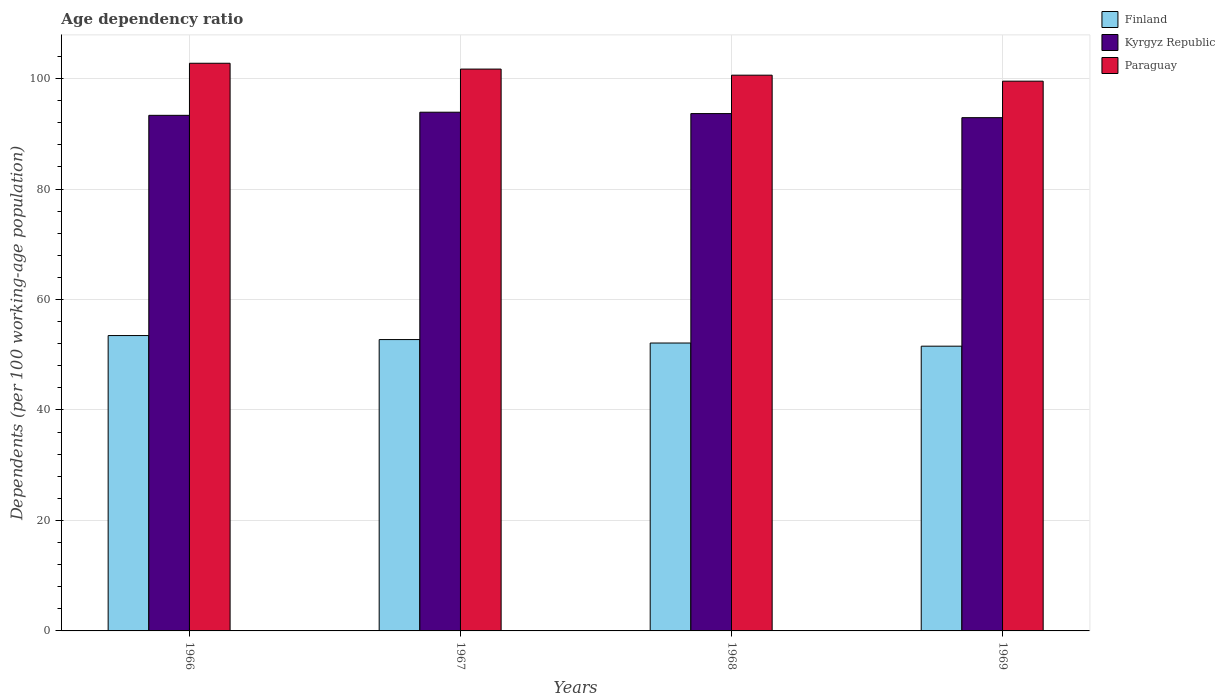How many groups of bars are there?
Provide a succinct answer. 4. How many bars are there on the 2nd tick from the right?
Provide a succinct answer. 3. What is the label of the 1st group of bars from the left?
Provide a short and direct response. 1966. What is the age dependency ratio in in Paraguay in 1969?
Provide a short and direct response. 99.53. Across all years, what is the maximum age dependency ratio in in Finland?
Your response must be concise. 53.48. Across all years, what is the minimum age dependency ratio in in Finland?
Your response must be concise. 51.55. In which year was the age dependency ratio in in Paraguay maximum?
Offer a terse response. 1966. In which year was the age dependency ratio in in Paraguay minimum?
Give a very brief answer. 1969. What is the total age dependency ratio in in Kyrgyz Republic in the graph?
Offer a very short reply. 373.85. What is the difference between the age dependency ratio in in Finland in 1966 and that in 1967?
Give a very brief answer. 0.73. What is the difference between the age dependency ratio in in Finland in 1968 and the age dependency ratio in in Paraguay in 1966?
Your answer should be compact. -50.65. What is the average age dependency ratio in in Paraguay per year?
Offer a very short reply. 101.16. In the year 1966, what is the difference between the age dependency ratio in in Finland and age dependency ratio in in Paraguay?
Provide a succinct answer. -49.3. In how many years, is the age dependency ratio in in Kyrgyz Republic greater than 100 %?
Provide a short and direct response. 0. What is the ratio of the age dependency ratio in in Kyrgyz Republic in 1966 to that in 1968?
Keep it short and to the point. 1. What is the difference between the highest and the second highest age dependency ratio in in Paraguay?
Ensure brevity in your answer.  1.06. What is the difference between the highest and the lowest age dependency ratio in in Kyrgyz Republic?
Give a very brief answer. 0.99. Is the sum of the age dependency ratio in in Finland in 1966 and 1967 greater than the maximum age dependency ratio in in Paraguay across all years?
Ensure brevity in your answer.  Yes. What does the 1st bar from the right in 1969 represents?
Offer a terse response. Paraguay. Is it the case that in every year, the sum of the age dependency ratio in in Paraguay and age dependency ratio in in Kyrgyz Republic is greater than the age dependency ratio in in Finland?
Your response must be concise. Yes. Are all the bars in the graph horizontal?
Your response must be concise. No. How many years are there in the graph?
Make the answer very short. 4. Are the values on the major ticks of Y-axis written in scientific E-notation?
Your answer should be very brief. No. Does the graph contain grids?
Your response must be concise. Yes. Where does the legend appear in the graph?
Give a very brief answer. Top right. What is the title of the graph?
Ensure brevity in your answer.  Age dependency ratio. What is the label or title of the X-axis?
Keep it short and to the point. Years. What is the label or title of the Y-axis?
Give a very brief answer. Dependents (per 100 working-age population). What is the Dependents (per 100 working-age population) in Finland in 1966?
Your response must be concise. 53.48. What is the Dependents (per 100 working-age population) in Kyrgyz Republic in 1966?
Your answer should be compact. 93.35. What is the Dependents (per 100 working-age population) in Paraguay in 1966?
Your answer should be compact. 102.78. What is the Dependents (per 100 working-age population) in Finland in 1967?
Offer a terse response. 52.75. What is the Dependents (per 100 working-age population) in Kyrgyz Republic in 1967?
Give a very brief answer. 93.91. What is the Dependents (per 100 working-age population) of Paraguay in 1967?
Offer a very short reply. 101.72. What is the Dependents (per 100 working-age population) in Finland in 1968?
Give a very brief answer. 52.13. What is the Dependents (per 100 working-age population) in Kyrgyz Republic in 1968?
Your answer should be very brief. 93.66. What is the Dependents (per 100 working-age population) of Paraguay in 1968?
Offer a terse response. 100.62. What is the Dependents (per 100 working-age population) of Finland in 1969?
Make the answer very short. 51.55. What is the Dependents (per 100 working-age population) of Kyrgyz Republic in 1969?
Offer a very short reply. 92.93. What is the Dependents (per 100 working-age population) in Paraguay in 1969?
Ensure brevity in your answer.  99.53. Across all years, what is the maximum Dependents (per 100 working-age population) in Finland?
Provide a short and direct response. 53.48. Across all years, what is the maximum Dependents (per 100 working-age population) of Kyrgyz Republic?
Your answer should be very brief. 93.91. Across all years, what is the maximum Dependents (per 100 working-age population) of Paraguay?
Ensure brevity in your answer.  102.78. Across all years, what is the minimum Dependents (per 100 working-age population) of Finland?
Your response must be concise. 51.55. Across all years, what is the minimum Dependents (per 100 working-age population) of Kyrgyz Republic?
Your answer should be compact. 92.93. Across all years, what is the minimum Dependents (per 100 working-age population) of Paraguay?
Your response must be concise. 99.53. What is the total Dependents (per 100 working-age population) in Finland in the graph?
Offer a very short reply. 209.9. What is the total Dependents (per 100 working-age population) in Kyrgyz Republic in the graph?
Your answer should be compact. 373.85. What is the total Dependents (per 100 working-age population) in Paraguay in the graph?
Offer a terse response. 404.65. What is the difference between the Dependents (per 100 working-age population) of Finland in 1966 and that in 1967?
Your answer should be compact. 0.73. What is the difference between the Dependents (per 100 working-age population) in Kyrgyz Republic in 1966 and that in 1967?
Provide a succinct answer. -0.56. What is the difference between the Dependents (per 100 working-age population) in Paraguay in 1966 and that in 1967?
Offer a very short reply. 1.06. What is the difference between the Dependents (per 100 working-age population) in Finland in 1966 and that in 1968?
Provide a short and direct response. 1.35. What is the difference between the Dependents (per 100 working-age population) in Kyrgyz Republic in 1966 and that in 1968?
Give a very brief answer. -0.32. What is the difference between the Dependents (per 100 working-age population) in Paraguay in 1966 and that in 1968?
Provide a short and direct response. 2.16. What is the difference between the Dependents (per 100 working-age population) in Finland in 1966 and that in 1969?
Give a very brief answer. 1.92. What is the difference between the Dependents (per 100 working-age population) of Kyrgyz Republic in 1966 and that in 1969?
Make the answer very short. 0.42. What is the difference between the Dependents (per 100 working-age population) of Paraguay in 1966 and that in 1969?
Offer a very short reply. 3.24. What is the difference between the Dependents (per 100 working-age population) in Finland in 1967 and that in 1968?
Offer a very short reply. 0.62. What is the difference between the Dependents (per 100 working-age population) of Kyrgyz Republic in 1967 and that in 1968?
Keep it short and to the point. 0.25. What is the difference between the Dependents (per 100 working-age population) of Paraguay in 1967 and that in 1968?
Ensure brevity in your answer.  1.1. What is the difference between the Dependents (per 100 working-age population) in Finland in 1967 and that in 1969?
Provide a succinct answer. 1.2. What is the difference between the Dependents (per 100 working-age population) in Kyrgyz Republic in 1967 and that in 1969?
Provide a succinct answer. 0.99. What is the difference between the Dependents (per 100 working-age population) in Paraguay in 1967 and that in 1969?
Provide a succinct answer. 2.19. What is the difference between the Dependents (per 100 working-age population) in Finland in 1968 and that in 1969?
Your response must be concise. 0.57. What is the difference between the Dependents (per 100 working-age population) of Kyrgyz Republic in 1968 and that in 1969?
Offer a very short reply. 0.74. What is the difference between the Dependents (per 100 working-age population) in Paraguay in 1968 and that in 1969?
Give a very brief answer. 1.08. What is the difference between the Dependents (per 100 working-age population) in Finland in 1966 and the Dependents (per 100 working-age population) in Kyrgyz Republic in 1967?
Offer a terse response. -40.44. What is the difference between the Dependents (per 100 working-age population) in Finland in 1966 and the Dependents (per 100 working-age population) in Paraguay in 1967?
Offer a very short reply. -48.24. What is the difference between the Dependents (per 100 working-age population) in Kyrgyz Republic in 1966 and the Dependents (per 100 working-age population) in Paraguay in 1967?
Make the answer very short. -8.37. What is the difference between the Dependents (per 100 working-age population) in Finland in 1966 and the Dependents (per 100 working-age population) in Kyrgyz Republic in 1968?
Your answer should be compact. -40.19. What is the difference between the Dependents (per 100 working-age population) in Finland in 1966 and the Dependents (per 100 working-age population) in Paraguay in 1968?
Your answer should be very brief. -47.14. What is the difference between the Dependents (per 100 working-age population) of Kyrgyz Republic in 1966 and the Dependents (per 100 working-age population) of Paraguay in 1968?
Provide a succinct answer. -7.27. What is the difference between the Dependents (per 100 working-age population) in Finland in 1966 and the Dependents (per 100 working-age population) in Kyrgyz Republic in 1969?
Your response must be concise. -39.45. What is the difference between the Dependents (per 100 working-age population) of Finland in 1966 and the Dependents (per 100 working-age population) of Paraguay in 1969?
Offer a very short reply. -46.06. What is the difference between the Dependents (per 100 working-age population) of Kyrgyz Republic in 1966 and the Dependents (per 100 working-age population) of Paraguay in 1969?
Ensure brevity in your answer.  -6.19. What is the difference between the Dependents (per 100 working-age population) of Finland in 1967 and the Dependents (per 100 working-age population) of Kyrgyz Republic in 1968?
Ensure brevity in your answer.  -40.91. What is the difference between the Dependents (per 100 working-age population) of Finland in 1967 and the Dependents (per 100 working-age population) of Paraguay in 1968?
Keep it short and to the point. -47.87. What is the difference between the Dependents (per 100 working-age population) of Kyrgyz Republic in 1967 and the Dependents (per 100 working-age population) of Paraguay in 1968?
Your answer should be compact. -6.7. What is the difference between the Dependents (per 100 working-age population) in Finland in 1967 and the Dependents (per 100 working-age population) in Kyrgyz Republic in 1969?
Give a very brief answer. -40.18. What is the difference between the Dependents (per 100 working-age population) of Finland in 1967 and the Dependents (per 100 working-age population) of Paraguay in 1969?
Keep it short and to the point. -46.79. What is the difference between the Dependents (per 100 working-age population) in Kyrgyz Republic in 1967 and the Dependents (per 100 working-age population) in Paraguay in 1969?
Offer a very short reply. -5.62. What is the difference between the Dependents (per 100 working-age population) in Finland in 1968 and the Dependents (per 100 working-age population) in Kyrgyz Republic in 1969?
Your answer should be very brief. -40.8. What is the difference between the Dependents (per 100 working-age population) of Finland in 1968 and the Dependents (per 100 working-age population) of Paraguay in 1969?
Your response must be concise. -47.41. What is the difference between the Dependents (per 100 working-age population) of Kyrgyz Republic in 1968 and the Dependents (per 100 working-age population) of Paraguay in 1969?
Make the answer very short. -5.87. What is the average Dependents (per 100 working-age population) of Finland per year?
Keep it short and to the point. 52.48. What is the average Dependents (per 100 working-age population) of Kyrgyz Republic per year?
Provide a succinct answer. 93.46. What is the average Dependents (per 100 working-age population) of Paraguay per year?
Offer a very short reply. 101.16. In the year 1966, what is the difference between the Dependents (per 100 working-age population) of Finland and Dependents (per 100 working-age population) of Kyrgyz Republic?
Your answer should be very brief. -39.87. In the year 1966, what is the difference between the Dependents (per 100 working-age population) in Finland and Dependents (per 100 working-age population) in Paraguay?
Provide a short and direct response. -49.3. In the year 1966, what is the difference between the Dependents (per 100 working-age population) in Kyrgyz Republic and Dependents (per 100 working-age population) in Paraguay?
Keep it short and to the point. -9.43. In the year 1967, what is the difference between the Dependents (per 100 working-age population) in Finland and Dependents (per 100 working-age population) in Kyrgyz Republic?
Ensure brevity in your answer.  -41.16. In the year 1967, what is the difference between the Dependents (per 100 working-age population) in Finland and Dependents (per 100 working-age population) in Paraguay?
Provide a succinct answer. -48.97. In the year 1967, what is the difference between the Dependents (per 100 working-age population) in Kyrgyz Republic and Dependents (per 100 working-age population) in Paraguay?
Give a very brief answer. -7.81. In the year 1968, what is the difference between the Dependents (per 100 working-age population) in Finland and Dependents (per 100 working-age population) in Kyrgyz Republic?
Provide a succinct answer. -41.54. In the year 1968, what is the difference between the Dependents (per 100 working-age population) of Finland and Dependents (per 100 working-age population) of Paraguay?
Ensure brevity in your answer.  -48.49. In the year 1968, what is the difference between the Dependents (per 100 working-age population) of Kyrgyz Republic and Dependents (per 100 working-age population) of Paraguay?
Offer a very short reply. -6.95. In the year 1969, what is the difference between the Dependents (per 100 working-age population) of Finland and Dependents (per 100 working-age population) of Kyrgyz Republic?
Ensure brevity in your answer.  -41.37. In the year 1969, what is the difference between the Dependents (per 100 working-age population) of Finland and Dependents (per 100 working-age population) of Paraguay?
Your response must be concise. -47.98. In the year 1969, what is the difference between the Dependents (per 100 working-age population) in Kyrgyz Republic and Dependents (per 100 working-age population) in Paraguay?
Provide a succinct answer. -6.61. What is the ratio of the Dependents (per 100 working-age population) in Finland in 1966 to that in 1967?
Your response must be concise. 1.01. What is the ratio of the Dependents (per 100 working-age population) in Kyrgyz Republic in 1966 to that in 1967?
Provide a short and direct response. 0.99. What is the ratio of the Dependents (per 100 working-age population) of Paraguay in 1966 to that in 1967?
Keep it short and to the point. 1.01. What is the ratio of the Dependents (per 100 working-age population) of Finland in 1966 to that in 1968?
Offer a very short reply. 1.03. What is the ratio of the Dependents (per 100 working-age population) of Paraguay in 1966 to that in 1968?
Your answer should be compact. 1.02. What is the ratio of the Dependents (per 100 working-age population) of Finland in 1966 to that in 1969?
Provide a succinct answer. 1.04. What is the ratio of the Dependents (per 100 working-age population) of Kyrgyz Republic in 1966 to that in 1969?
Offer a terse response. 1. What is the ratio of the Dependents (per 100 working-age population) in Paraguay in 1966 to that in 1969?
Your response must be concise. 1.03. What is the ratio of the Dependents (per 100 working-age population) of Finland in 1967 to that in 1968?
Your answer should be compact. 1.01. What is the ratio of the Dependents (per 100 working-age population) of Kyrgyz Republic in 1967 to that in 1968?
Offer a very short reply. 1. What is the ratio of the Dependents (per 100 working-age population) of Paraguay in 1967 to that in 1968?
Ensure brevity in your answer.  1.01. What is the ratio of the Dependents (per 100 working-age population) in Finland in 1967 to that in 1969?
Provide a succinct answer. 1.02. What is the ratio of the Dependents (per 100 working-age population) of Kyrgyz Republic in 1967 to that in 1969?
Ensure brevity in your answer.  1.01. What is the ratio of the Dependents (per 100 working-age population) of Paraguay in 1967 to that in 1969?
Offer a terse response. 1.02. What is the ratio of the Dependents (per 100 working-age population) of Finland in 1968 to that in 1969?
Offer a terse response. 1.01. What is the ratio of the Dependents (per 100 working-age population) of Kyrgyz Republic in 1968 to that in 1969?
Your response must be concise. 1.01. What is the ratio of the Dependents (per 100 working-age population) in Paraguay in 1968 to that in 1969?
Your answer should be compact. 1.01. What is the difference between the highest and the second highest Dependents (per 100 working-age population) of Finland?
Ensure brevity in your answer.  0.73. What is the difference between the highest and the second highest Dependents (per 100 working-age population) in Kyrgyz Republic?
Provide a short and direct response. 0.25. What is the difference between the highest and the second highest Dependents (per 100 working-age population) of Paraguay?
Your response must be concise. 1.06. What is the difference between the highest and the lowest Dependents (per 100 working-age population) in Finland?
Your answer should be compact. 1.92. What is the difference between the highest and the lowest Dependents (per 100 working-age population) in Kyrgyz Republic?
Your response must be concise. 0.99. What is the difference between the highest and the lowest Dependents (per 100 working-age population) in Paraguay?
Offer a terse response. 3.24. 